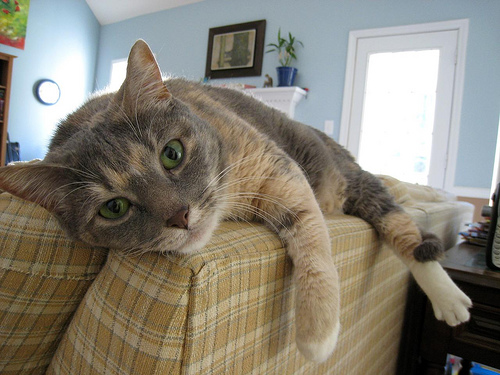Can you describe the room environment the cat is in? From the angle of the photo, we can observe that the cat is in a brightly lit room with soft blue walls. There's a door with sunlight streaming in from the window, suggesting it might be a sunny day outside. The cozy ambiance is typical of a relaxed home setting. 